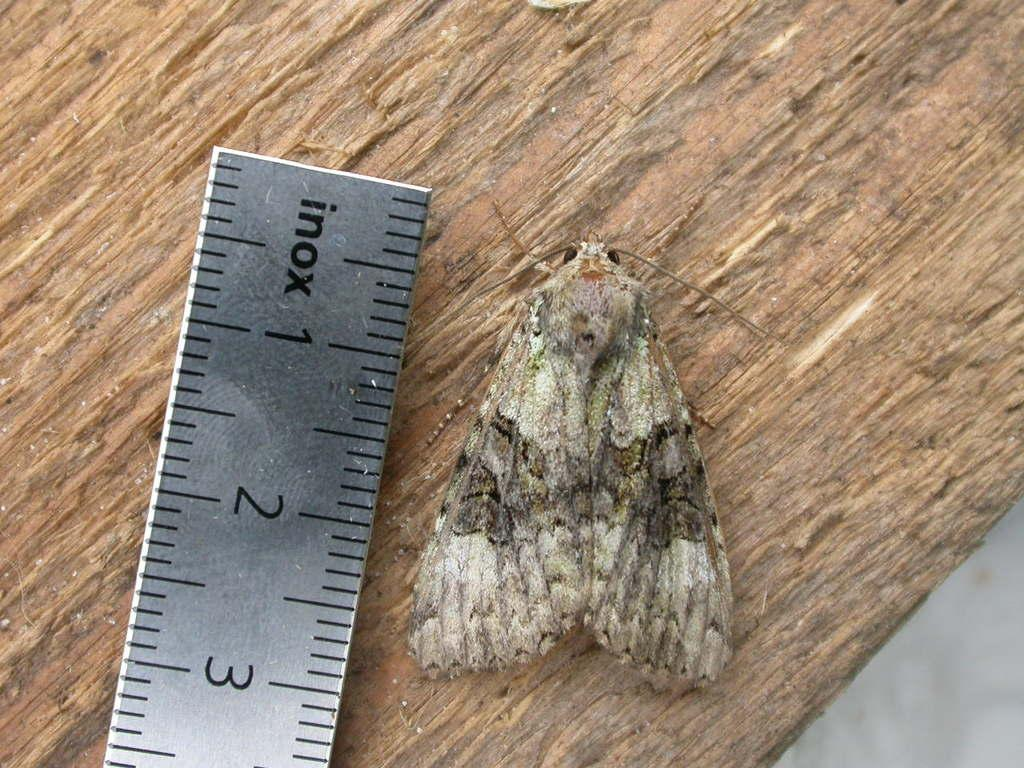<image>
Share a concise interpretation of the image provided. An Inox ruler in inches lays on a wood surface. 